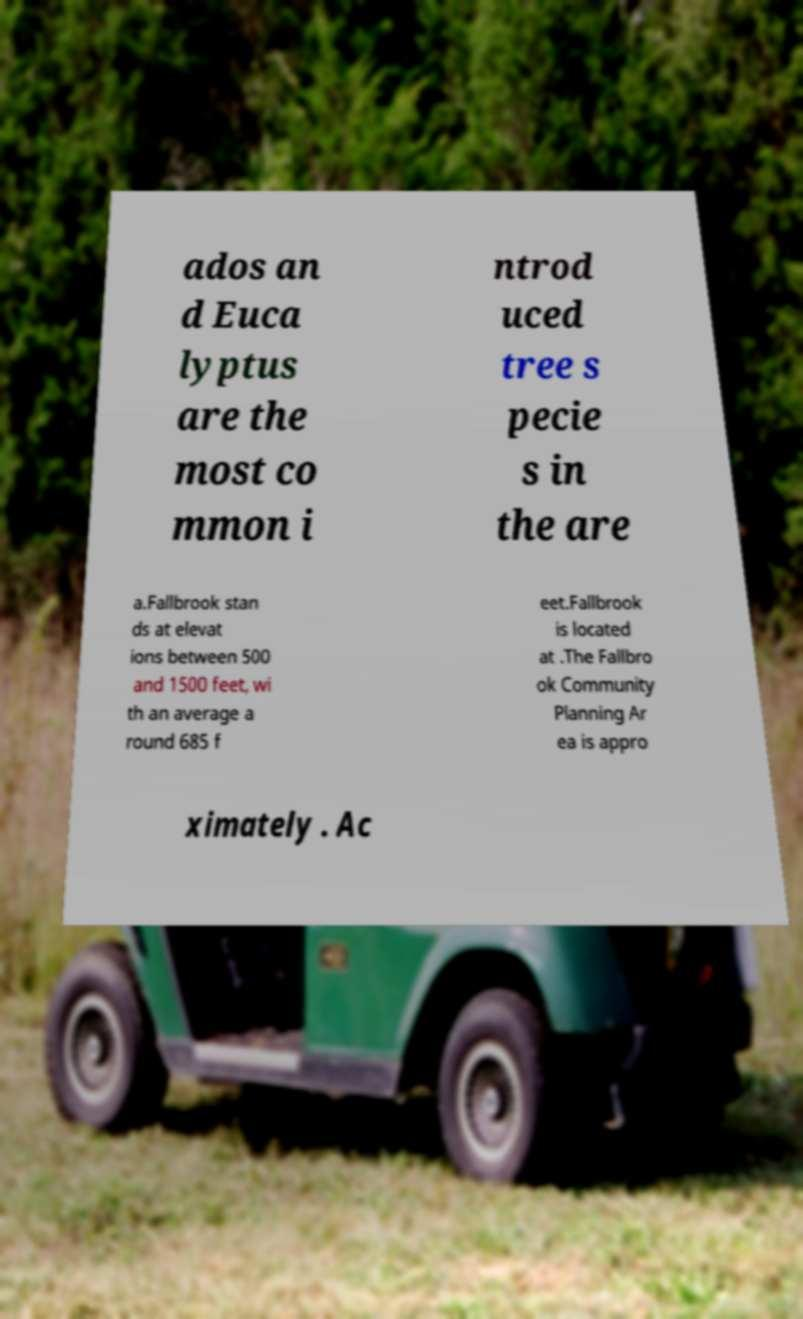There's text embedded in this image that I need extracted. Can you transcribe it verbatim? ados an d Euca lyptus are the most co mmon i ntrod uced tree s pecie s in the are a.Fallbrook stan ds at elevat ions between 500 and 1500 feet, wi th an average a round 685 f eet.Fallbrook is located at .The Fallbro ok Community Planning Ar ea is appro ximately . Ac 